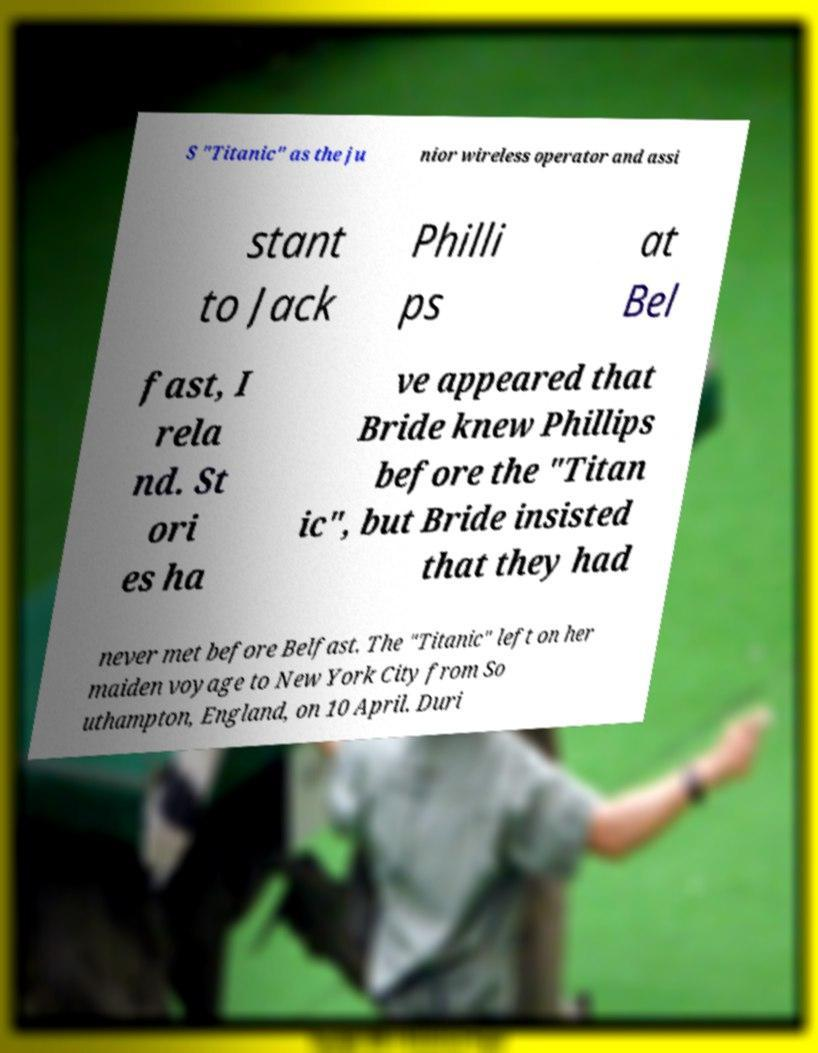I need the written content from this picture converted into text. Can you do that? S "Titanic" as the ju nior wireless operator and assi stant to Jack Philli ps at Bel fast, I rela nd. St ori es ha ve appeared that Bride knew Phillips before the "Titan ic", but Bride insisted that they had never met before Belfast. The "Titanic" left on her maiden voyage to New York City from So uthampton, England, on 10 April. Duri 